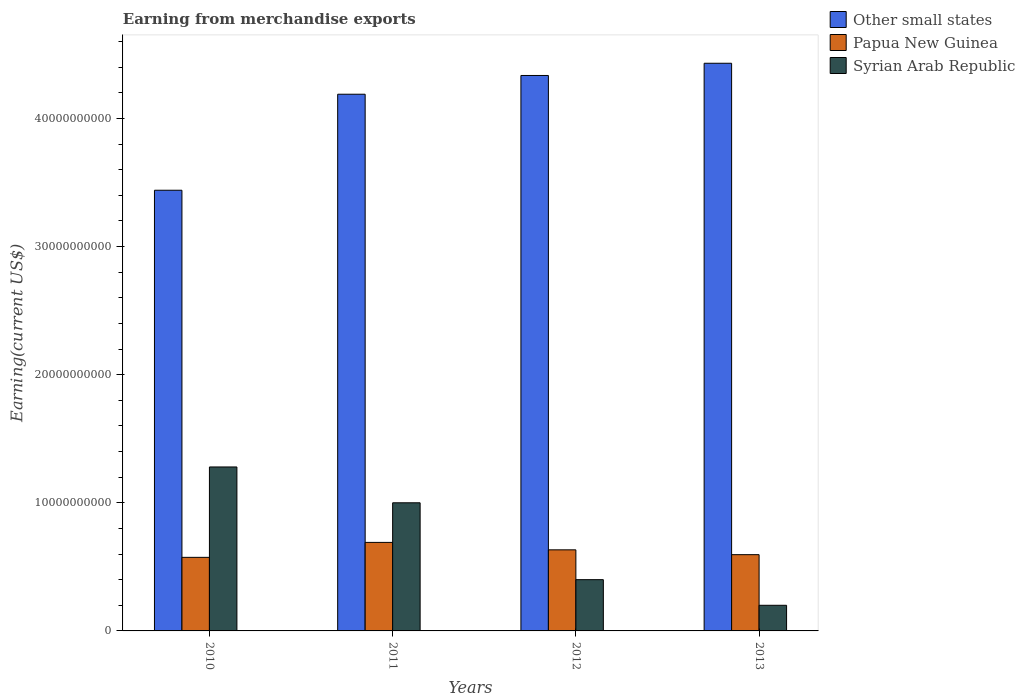Are the number of bars per tick equal to the number of legend labels?
Your response must be concise. Yes. In how many cases, is the number of bars for a given year not equal to the number of legend labels?
Offer a very short reply. 0. What is the amount earned from merchandise exports in Other small states in 2013?
Keep it short and to the point. 4.43e+1. Across all years, what is the maximum amount earned from merchandise exports in Other small states?
Provide a succinct answer. 4.43e+1. Across all years, what is the minimum amount earned from merchandise exports in Syrian Arab Republic?
Give a very brief answer. 2.00e+09. What is the total amount earned from merchandise exports in Papua New Guinea in the graph?
Your response must be concise. 2.49e+1. What is the difference between the amount earned from merchandise exports in Papua New Guinea in 2010 and that in 2013?
Provide a succinct answer. -2.09e+08. What is the difference between the amount earned from merchandise exports in Syrian Arab Republic in 2010 and the amount earned from merchandise exports in Other small states in 2013?
Provide a succinct answer. -3.15e+1. What is the average amount earned from merchandise exports in Papua New Guinea per year?
Keep it short and to the point. 6.23e+09. In the year 2010, what is the difference between the amount earned from merchandise exports in Syrian Arab Republic and amount earned from merchandise exports in Other small states?
Your answer should be very brief. -2.16e+1. In how many years, is the amount earned from merchandise exports in Other small states greater than 2000000000 US$?
Ensure brevity in your answer.  4. What is the ratio of the amount earned from merchandise exports in Other small states in 2012 to that in 2013?
Offer a very short reply. 0.98. Is the amount earned from merchandise exports in Other small states in 2011 less than that in 2012?
Make the answer very short. Yes. What is the difference between the highest and the second highest amount earned from merchandise exports in Papua New Guinea?
Offer a terse response. 5.81e+08. What is the difference between the highest and the lowest amount earned from merchandise exports in Syrian Arab Republic?
Keep it short and to the point. 1.08e+1. In how many years, is the amount earned from merchandise exports in Syrian Arab Republic greater than the average amount earned from merchandise exports in Syrian Arab Republic taken over all years?
Your answer should be very brief. 2. Is the sum of the amount earned from merchandise exports in Papua New Guinea in 2011 and 2013 greater than the maximum amount earned from merchandise exports in Other small states across all years?
Keep it short and to the point. No. What does the 3rd bar from the left in 2013 represents?
Your answer should be very brief. Syrian Arab Republic. What does the 2nd bar from the right in 2010 represents?
Ensure brevity in your answer.  Papua New Guinea. What is the difference between two consecutive major ticks on the Y-axis?
Your answer should be very brief. 1.00e+1. Are the values on the major ticks of Y-axis written in scientific E-notation?
Give a very brief answer. No. Where does the legend appear in the graph?
Offer a terse response. Top right. How many legend labels are there?
Your response must be concise. 3. How are the legend labels stacked?
Make the answer very short. Vertical. What is the title of the graph?
Make the answer very short. Earning from merchandise exports. Does "Other small states" appear as one of the legend labels in the graph?
Offer a terse response. Yes. What is the label or title of the Y-axis?
Keep it short and to the point. Earning(current US$). What is the Earning(current US$) of Other small states in 2010?
Offer a very short reply. 3.44e+1. What is the Earning(current US$) in Papua New Guinea in 2010?
Your answer should be compact. 5.74e+09. What is the Earning(current US$) in Syrian Arab Republic in 2010?
Offer a very short reply. 1.28e+1. What is the Earning(current US$) of Other small states in 2011?
Your answer should be very brief. 4.19e+1. What is the Earning(current US$) in Papua New Guinea in 2011?
Your response must be concise. 6.91e+09. What is the Earning(current US$) of Syrian Arab Republic in 2011?
Ensure brevity in your answer.  1.00e+1. What is the Earning(current US$) in Other small states in 2012?
Your answer should be very brief. 4.33e+1. What is the Earning(current US$) in Papua New Guinea in 2012?
Ensure brevity in your answer.  6.33e+09. What is the Earning(current US$) of Syrian Arab Republic in 2012?
Ensure brevity in your answer.  4.00e+09. What is the Earning(current US$) of Other small states in 2013?
Provide a succinct answer. 4.43e+1. What is the Earning(current US$) in Papua New Guinea in 2013?
Offer a very short reply. 5.95e+09. What is the Earning(current US$) of Syrian Arab Republic in 2013?
Make the answer very short. 2.00e+09. Across all years, what is the maximum Earning(current US$) in Other small states?
Provide a succinct answer. 4.43e+1. Across all years, what is the maximum Earning(current US$) of Papua New Guinea?
Your answer should be very brief. 6.91e+09. Across all years, what is the maximum Earning(current US$) of Syrian Arab Republic?
Offer a terse response. 1.28e+1. Across all years, what is the minimum Earning(current US$) in Other small states?
Offer a very short reply. 3.44e+1. Across all years, what is the minimum Earning(current US$) of Papua New Guinea?
Provide a succinct answer. 5.74e+09. What is the total Earning(current US$) in Other small states in the graph?
Your answer should be very brief. 1.64e+11. What is the total Earning(current US$) in Papua New Guinea in the graph?
Your answer should be compact. 2.49e+1. What is the total Earning(current US$) of Syrian Arab Republic in the graph?
Make the answer very short. 2.88e+1. What is the difference between the Earning(current US$) of Other small states in 2010 and that in 2011?
Ensure brevity in your answer.  -7.49e+09. What is the difference between the Earning(current US$) of Papua New Guinea in 2010 and that in 2011?
Provide a short and direct response. -1.17e+09. What is the difference between the Earning(current US$) in Syrian Arab Republic in 2010 and that in 2011?
Your response must be concise. 2.80e+09. What is the difference between the Earning(current US$) in Other small states in 2010 and that in 2012?
Keep it short and to the point. -8.96e+09. What is the difference between the Earning(current US$) in Papua New Guinea in 2010 and that in 2012?
Provide a succinct answer. -5.86e+08. What is the difference between the Earning(current US$) of Syrian Arab Republic in 2010 and that in 2012?
Your answer should be very brief. 8.80e+09. What is the difference between the Earning(current US$) in Other small states in 2010 and that in 2013?
Ensure brevity in your answer.  -9.91e+09. What is the difference between the Earning(current US$) in Papua New Guinea in 2010 and that in 2013?
Provide a succinct answer. -2.09e+08. What is the difference between the Earning(current US$) of Syrian Arab Republic in 2010 and that in 2013?
Give a very brief answer. 1.08e+1. What is the difference between the Earning(current US$) of Other small states in 2011 and that in 2012?
Offer a very short reply. -1.46e+09. What is the difference between the Earning(current US$) in Papua New Guinea in 2011 and that in 2012?
Ensure brevity in your answer.  5.81e+08. What is the difference between the Earning(current US$) in Syrian Arab Republic in 2011 and that in 2012?
Provide a short and direct response. 6.00e+09. What is the difference between the Earning(current US$) of Other small states in 2011 and that in 2013?
Provide a succinct answer. -2.42e+09. What is the difference between the Earning(current US$) of Papua New Guinea in 2011 and that in 2013?
Your answer should be compact. 9.57e+08. What is the difference between the Earning(current US$) of Syrian Arab Republic in 2011 and that in 2013?
Provide a short and direct response. 8.00e+09. What is the difference between the Earning(current US$) in Other small states in 2012 and that in 2013?
Your response must be concise. -9.54e+08. What is the difference between the Earning(current US$) in Papua New Guinea in 2012 and that in 2013?
Your answer should be compact. 3.77e+08. What is the difference between the Earning(current US$) of Other small states in 2010 and the Earning(current US$) of Papua New Guinea in 2011?
Your response must be concise. 2.75e+1. What is the difference between the Earning(current US$) in Other small states in 2010 and the Earning(current US$) in Syrian Arab Republic in 2011?
Give a very brief answer. 2.44e+1. What is the difference between the Earning(current US$) of Papua New Guinea in 2010 and the Earning(current US$) of Syrian Arab Republic in 2011?
Your answer should be very brief. -4.26e+09. What is the difference between the Earning(current US$) in Other small states in 2010 and the Earning(current US$) in Papua New Guinea in 2012?
Keep it short and to the point. 2.81e+1. What is the difference between the Earning(current US$) in Other small states in 2010 and the Earning(current US$) in Syrian Arab Republic in 2012?
Give a very brief answer. 3.04e+1. What is the difference between the Earning(current US$) in Papua New Guinea in 2010 and the Earning(current US$) in Syrian Arab Republic in 2012?
Provide a short and direct response. 1.74e+09. What is the difference between the Earning(current US$) in Other small states in 2010 and the Earning(current US$) in Papua New Guinea in 2013?
Ensure brevity in your answer.  2.84e+1. What is the difference between the Earning(current US$) in Other small states in 2010 and the Earning(current US$) in Syrian Arab Republic in 2013?
Provide a succinct answer. 3.24e+1. What is the difference between the Earning(current US$) in Papua New Guinea in 2010 and the Earning(current US$) in Syrian Arab Republic in 2013?
Ensure brevity in your answer.  3.74e+09. What is the difference between the Earning(current US$) in Other small states in 2011 and the Earning(current US$) in Papua New Guinea in 2012?
Your answer should be compact. 3.56e+1. What is the difference between the Earning(current US$) of Other small states in 2011 and the Earning(current US$) of Syrian Arab Republic in 2012?
Provide a short and direct response. 3.79e+1. What is the difference between the Earning(current US$) of Papua New Guinea in 2011 and the Earning(current US$) of Syrian Arab Republic in 2012?
Offer a very short reply. 2.91e+09. What is the difference between the Earning(current US$) in Other small states in 2011 and the Earning(current US$) in Papua New Guinea in 2013?
Ensure brevity in your answer.  3.59e+1. What is the difference between the Earning(current US$) of Other small states in 2011 and the Earning(current US$) of Syrian Arab Republic in 2013?
Your answer should be compact. 3.99e+1. What is the difference between the Earning(current US$) of Papua New Guinea in 2011 and the Earning(current US$) of Syrian Arab Republic in 2013?
Your response must be concise. 4.91e+09. What is the difference between the Earning(current US$) in Other small states in 2012 and the Earning(current US$) in Papua New Guinea in 2013?
Ensure brevity in your answer.  3.74e+1. What is the difference between the Earning(current US$) of Other small states in 2012 and the Earning(current US$) of Syrian Arab Republic in 2013?
Ensure brevity in your answer.  4.13e+1. What is the difference between the Earning(current US$) in Papua New Guinea in 2012 and the Earning(current US$) in Syrian Arab Republic in 2013?
Provide a short and direct response. 4.33e+09. What is the average Earning(current US$) of Other small states per year?
Provide a succinct answer. 4.10e+1. What is the average Earning(current US$) of Papua New Guinea per year?
Ensure brevity in your answer.  6.23e+09. What is the average Earning(current US$) of Syrian Arab Republic per year?
Provide a succinct answer. 7.20e+09. In the year 2010, what is the difference between the Earning(current US$) in Other small states and Earning(current US$) in Papua New Guinea?
Offer a terse response. 2.87e+1. In the year 2010, what is the difference between the Earning(current US$) in Other small states and Earning(current US$) in Syrian Arab Republic?
Ensure brevity in your answer.  2.16e+1. In the year 2010, what is the difference between the Earning(current US$) in Papua New Guinea and Earning(current US$) in Syrian Arab Republic?
Make the answer very short. -7.05e+09. In the year 2011, what is the difference between the Earning(current US$) in Other small states and Earning(current US$) in Papua New Guinea?
Your response must be concise. 3.50e+1. In the year 2011, what is the difference between the Earning(current US$) in Other small states and Earning(current US$) in Syrian Arab Republic?
Offer a very short reply. 3.19e+1. In the year 2011, what is the difference between the Earning(current US$) of Papua New Guinea and Earning(current US$) of Syrian Arab Republic?
Keep it short and to the point. -3.09e+09. In the year 2012, what is the difference between the Earning(current US$) of Other small states and Earning(current US$) of Papua New Guinea?
Your answer should be compact. 3.70e+1. In the year 2012, what is the difference between the Earning(current US$) in Other small states and Earning(current US$) in Syrian Arab Republic?
Give a very brief answer. 3.93e+1. In the year 2012, what is the difference between the Earning(current US$) of Papua New Guinea and Earning(current US$) of Syrian Arab Republic?
Keep it short and to the point. 2.33e+09. In the year 2013, what is the difference between the Earning(current US$) of Other small states and Earning(current US$) of Papua New Guinea?
Your answer should be very brief. 3.84e+1. In the year 2013, what is the difference between the Earning(current US$) of Other small states and Earning(current US$) of Syrian Arab Republic?
Offer a terse response. 4.23e+1. In the year 2013, what is the difference between the Earning(current US$) in Papua New Guinea and Earning(current US$) in Syrian Arab Republic?
Make the answer very short. 3.95e+09. What is the ratio of the Earning(current US$) of Other small states in 2010 to that in 2011?
Make the answer very short. 0.82. What is the ratio of the Earning(current US$) in Papua New Guinea in 2010 to that in 2011?
Your answer should be very brief. 0.83. What is the ratio of the Earning(current US$) of Syrian Arab Republic in 2010 to that in 2011?
Offer a very short reply. 1.28. What is the ratio of the Earning(current US$) of Other small states in 2010 to that in 2012?
Provide a short and direct response. 0.79. What is the ratio of the Earning(current US$) of Papua New Guinea in 2010 to that in 2012?
Keep it short and to the point. 0.91. What is the ratio of the Earning(current US$) in Syrian Arab Republic in 2010 to that in 2012?
Provide a succinct answer. 3.2. What is the ratio of the Earning(current US$) of Other small states in 2010 to that in 2013?
Keep it short and to the point. 0.78. What is the ratio of the Earning(current US$) of Papua New Guinea in 2010 to that in 2013?
Make the answer very short. 0.96. What is the ratio of the Earning(current US$) in Syrian Arab Republic in 2010 to that in 2013?
Your response must be concise. 6.4. What is the ratio of the Earning(current US$) in Other small states in 2011 to that in 2012?
Ensure brevity in your answer.  0.97. What is the ratio of the Earning(current US$) in Papua New Guinea in 2011 to that in 2012?
Make the answer very short. 1.09. What is the ratio of the Earning(current US$) in Other small states in 2011 to that in 2013?
Your response must be concise. 0.95. What is the ratio of the Earning(current US$) in Papua New Guinea in 2011 to that in 2013?
Your answer should be very brief. 1.16. What is the ratio of the Earning(current US$) in Other small states in 2012 to that in 2013?
Ensure brevity in your answer.  0.98. What is the ratio of the Earning(current US$) in Papua New Guinea in 2012 to that in 2013?
Your response must be concise. 1.06. What is the ratio of the Earning(current US$) of Syrian Arab Republic in 2012 to that in 2013?
Provide a short and direct response. 2. What is the difference between the highest and the second highest Earning(current US$) in Other small states?
Offer a very short reply. 9.54e+08. What is the difference between the highest and the second highest Earning(current US$) of Papua New Guinea?
Provide a succinct answer. 5.81e+08. What is the difference between the highest and the second highest Earning(current US$) of Syrian Arab Republic?
Offer a very short reply. 2.80e+09. What is the difference between the highest and the lowest Earning(current US$) in Other small states?
Offer a terse response. 9.91e+09. What is the difference between the highest and the lowest Earning(current US$) in Papua New Guinea?
Ensure brevity in your answer.  1.17e+09. What is the difference between the highest and the lowest Earning(current US$) of Syrian Arab Republic?
Your response must be concise. 1.08e+1. 